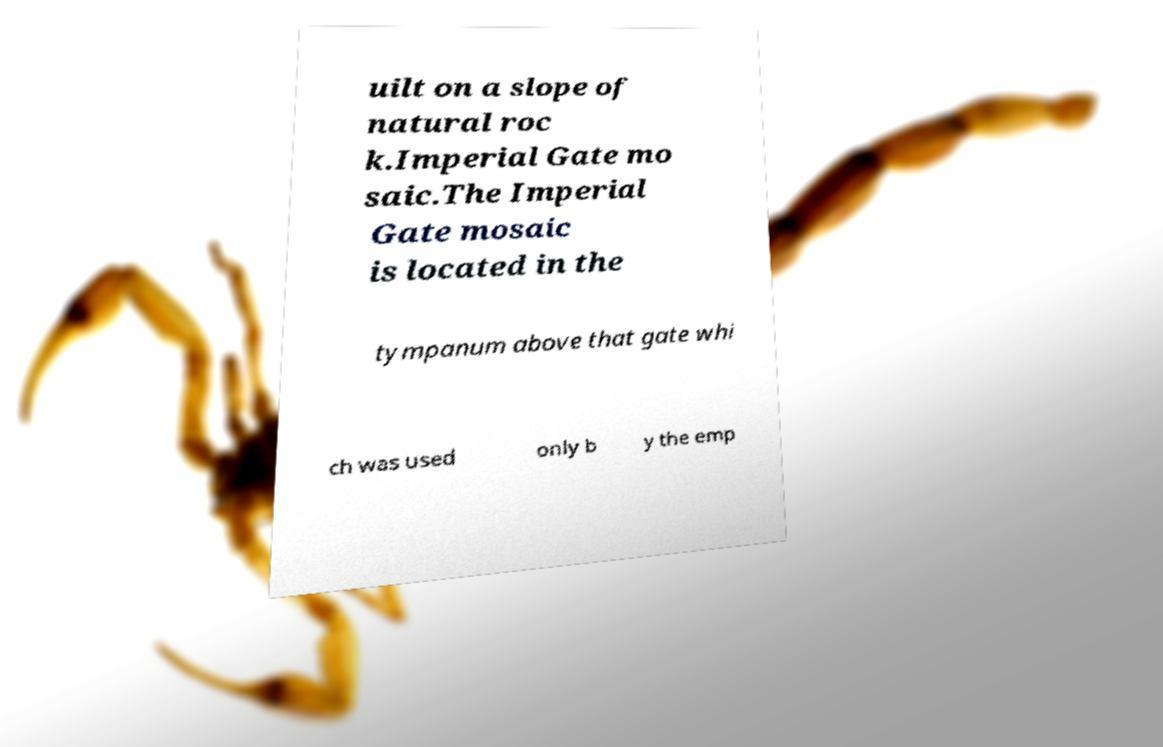Can you accurately transcribe the text from the provided image for me? uilt on a slope of natural roc k.Imperial Gate mo saic.The Imperial Gate mosaic is located in the tympanum above that gate whi ch was used only b y the emp 